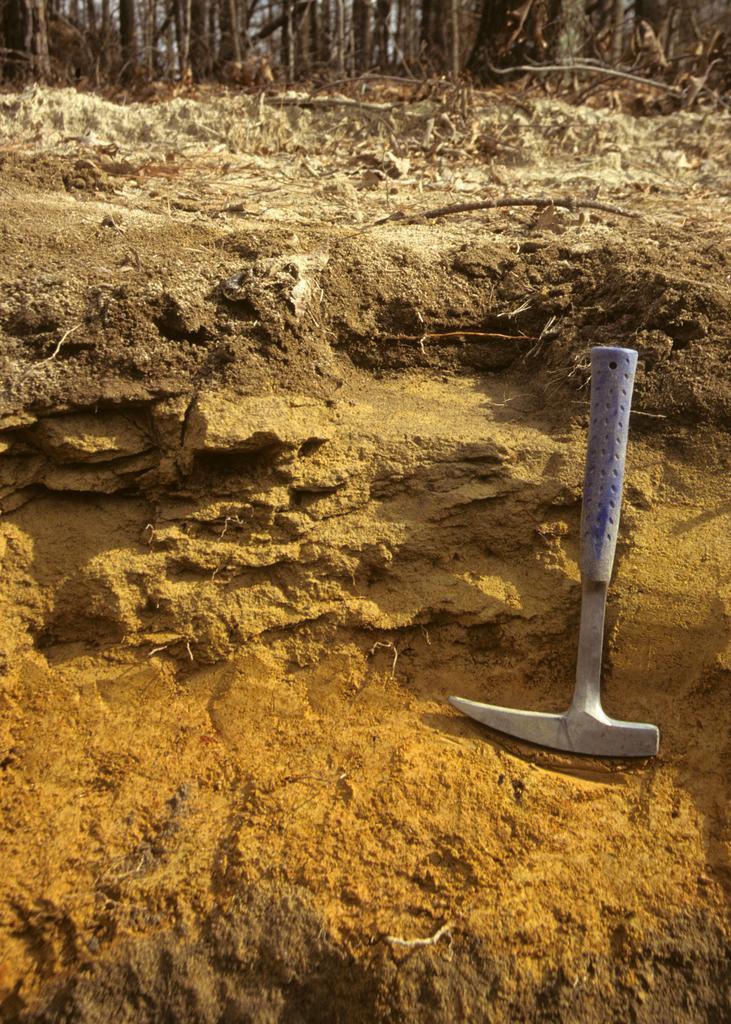Can you describe this image briefly? In this image on the right side we can see a tool on the ground. In the background at the top we can see leaves and sticks on the ground. 